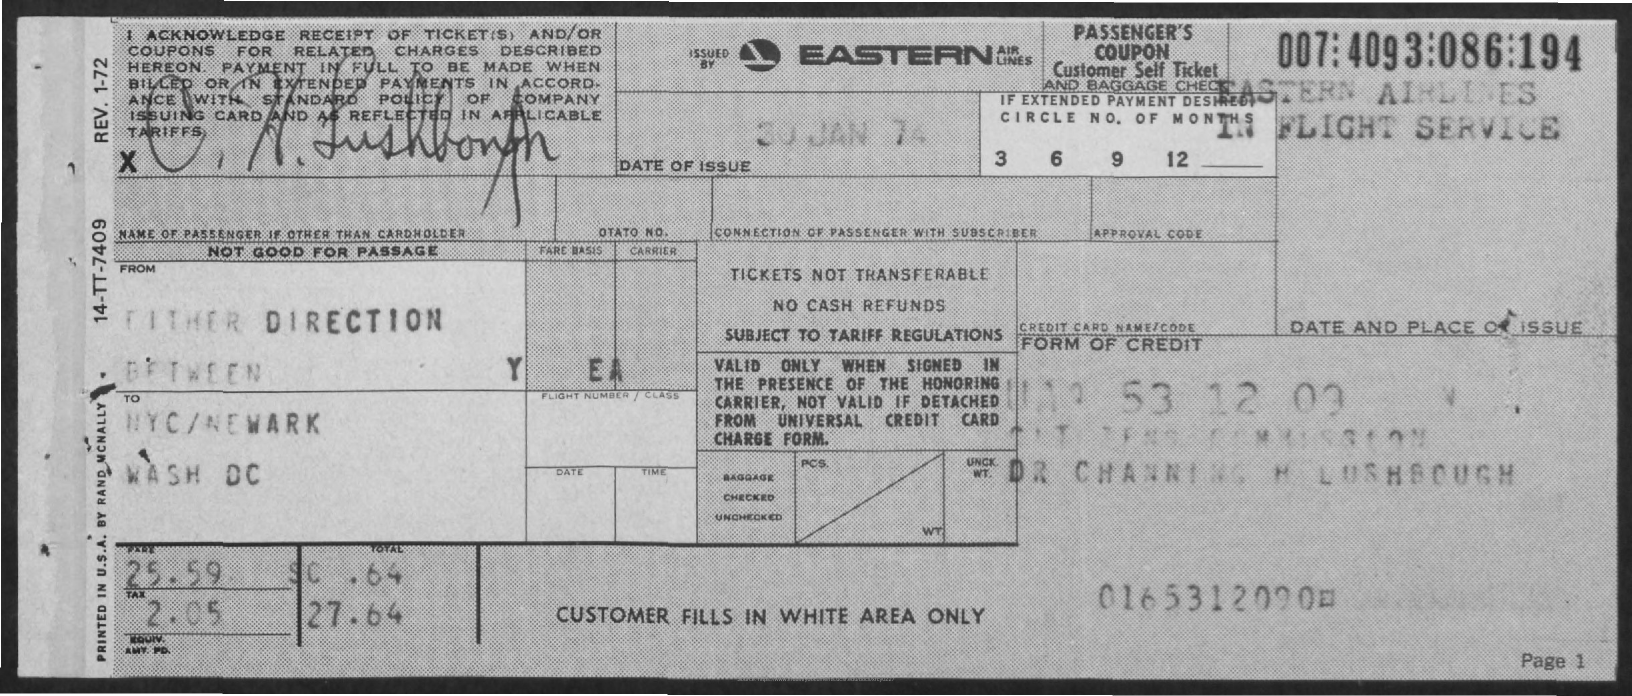What is the date of issue
Provide a short and direct response. 30 Jan 74. What is the name of the airlines
Offer a very short reply. Eastern airlines. 